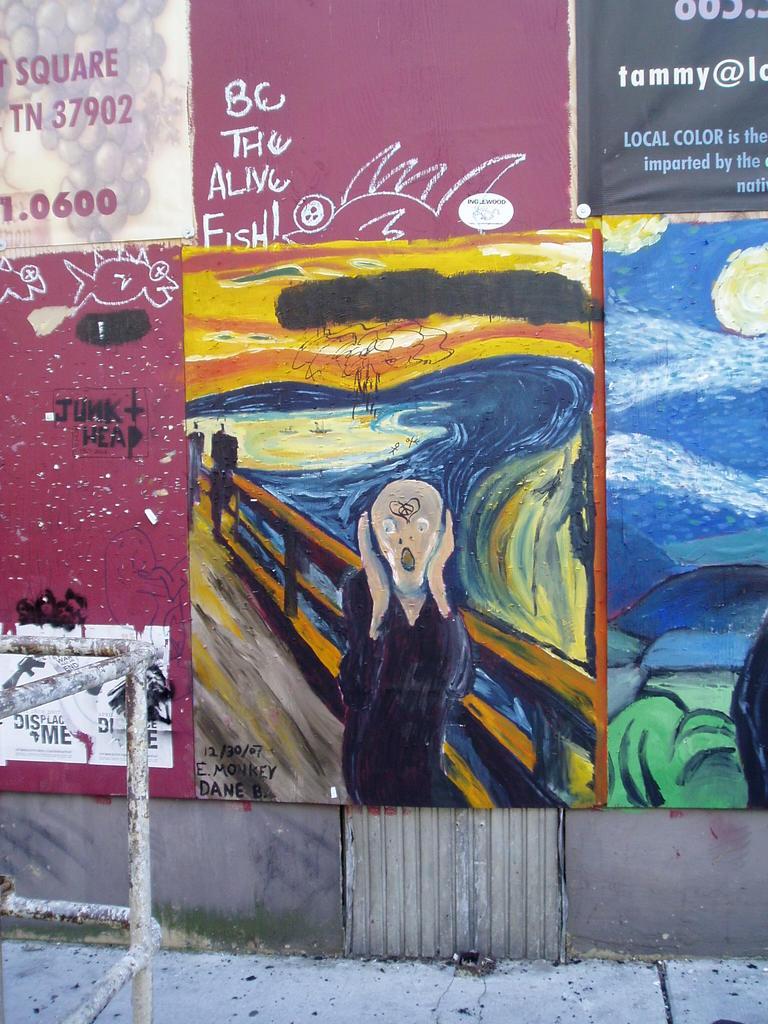What shape does the top left word say?
Your response must be concise. Square. 